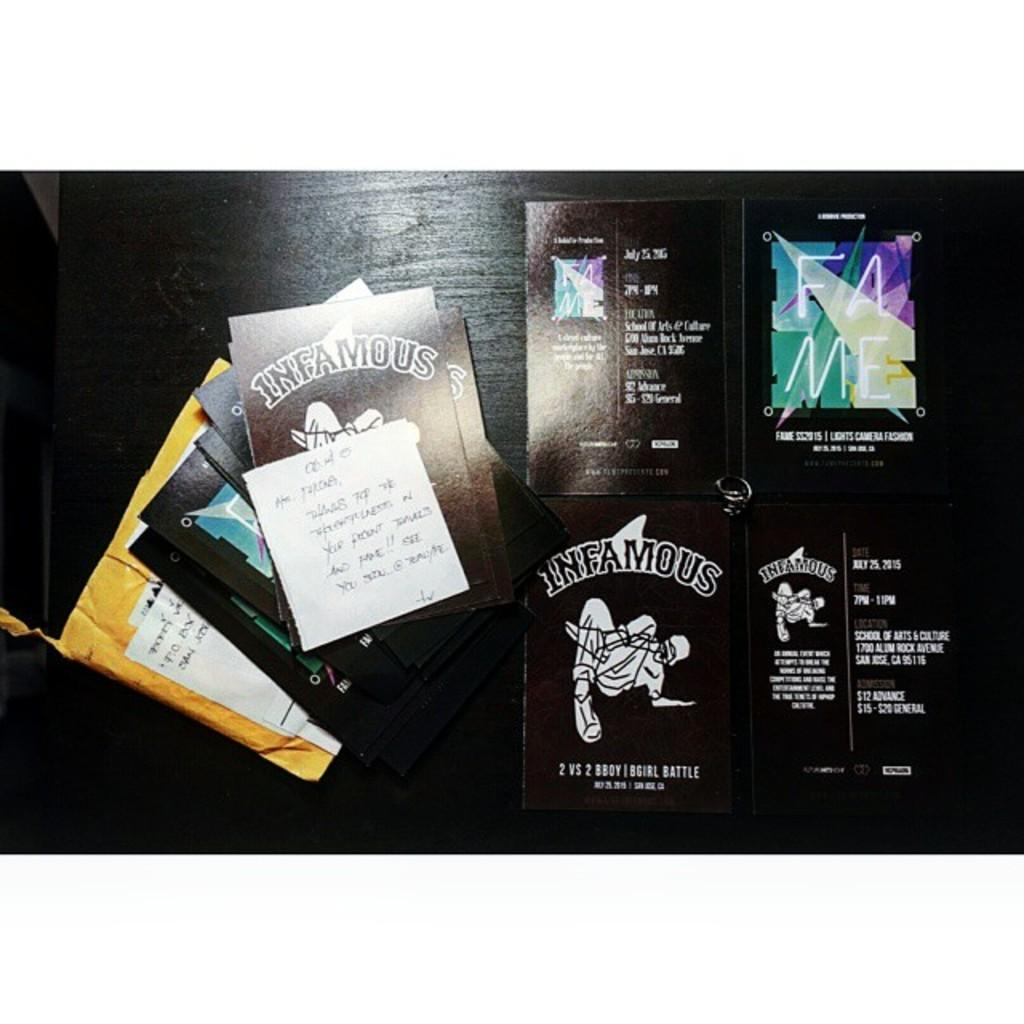<image>
Share a concise interpretation of the image provided. Some cards, many of which are black and one bearing the word Infamous. 